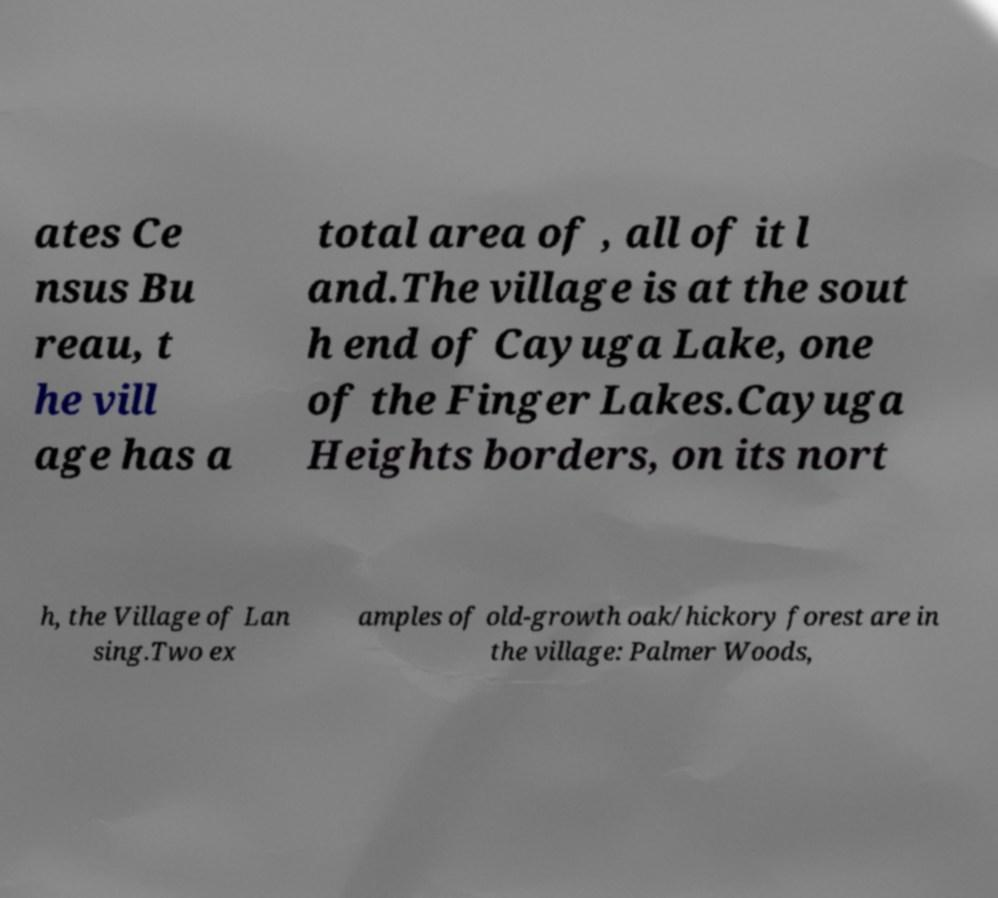Can you accurately transcribe the text from the provided image for me? ates Ce nsus Bu reau, t he vill age has a total area of , all of it l and.The village is at the sout h end of Cayuga Lake, one of the Finger Lakes.Cayuga Heights borders, on its nort h, the Village of Lan sing.Two ex amples of old-growth oak/hickory forest are in the village: Palmer Woods, 